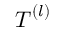<formula> <loc_0><loc_0><loc_500><loc_500>{ T } ^ { ( l ) }</formula> 